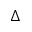Convert formula to latex. <formula><loc_0><loc_0><loc_500><loc_500>\Delta</formula> 